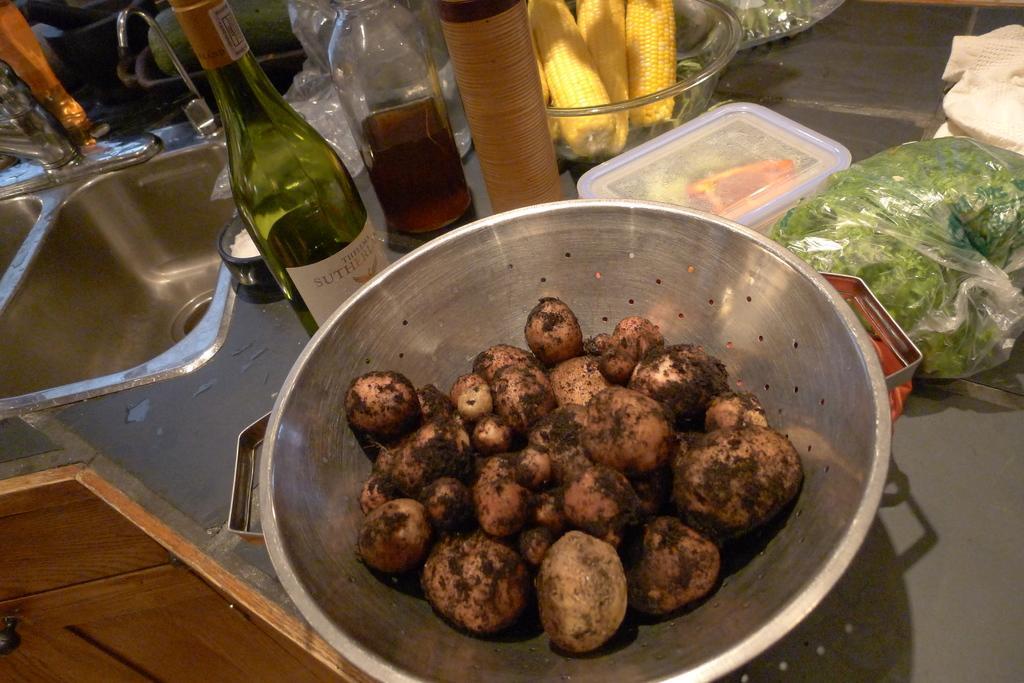Can you describe this image briefly? Here we can see a bowl of food in it and beside that we can see bottle of wine and there are boxes and there is corn present and beside that we can see a sink 